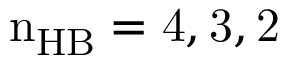Convert formula to latex. <formula><loc_0><loc_0><loc_500><loc_500>n _ { H B } = 4 , 3 , 2</formula> 